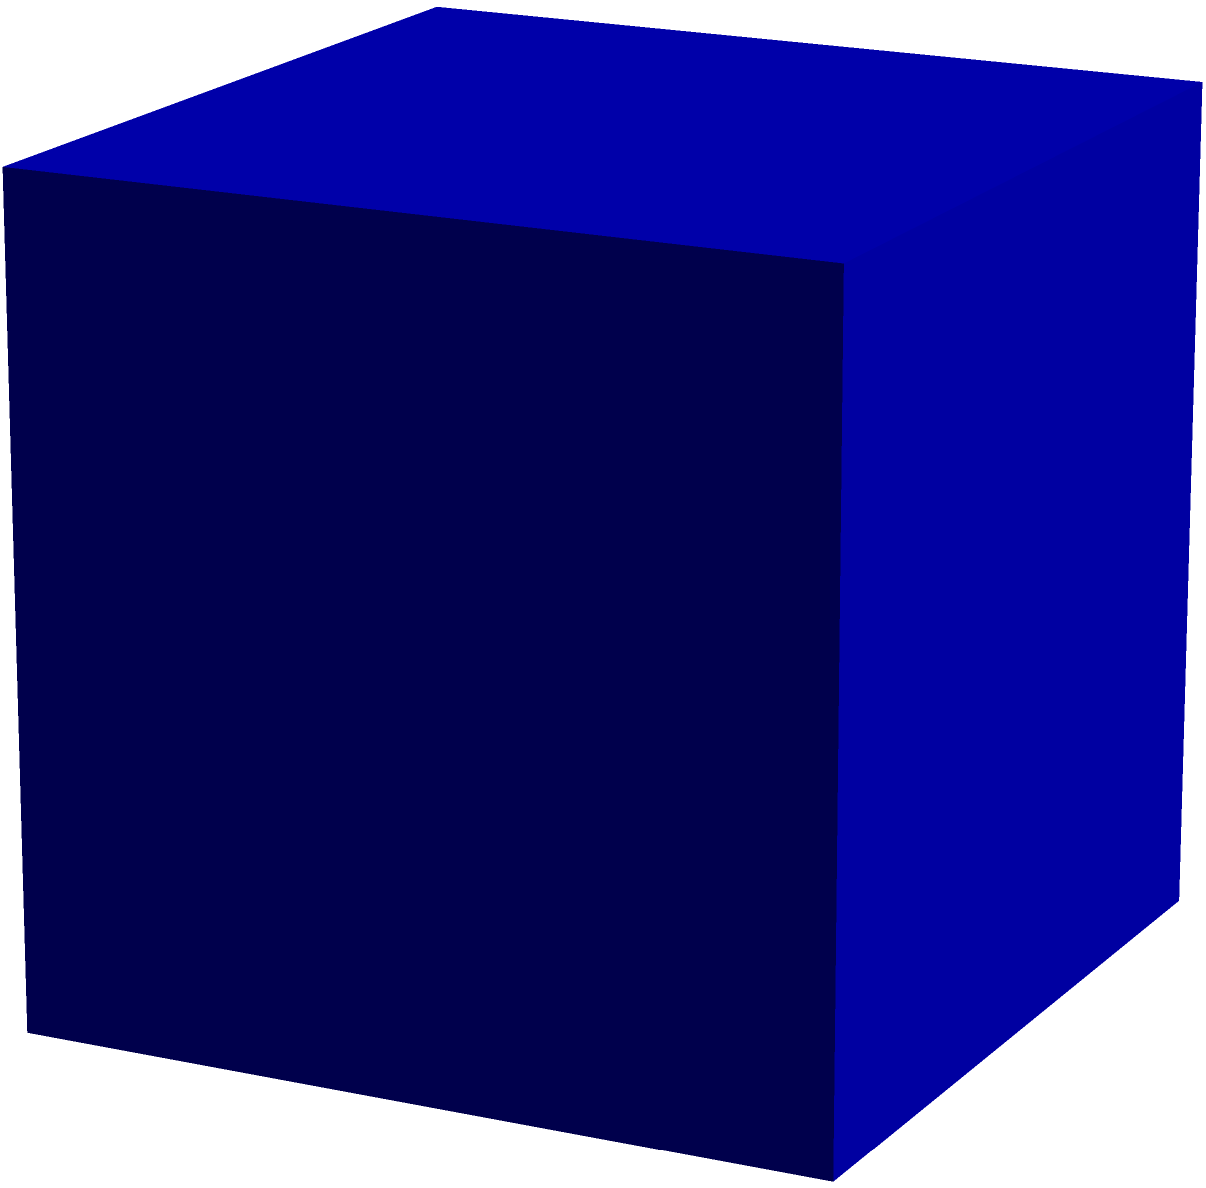In a cube with side length $a$, a sphere is inscribed such that it touches all faces of the cube. What is the volume of this inscribed sphere in terms of $a$? Let's approach this step-by-step:

1) First, we need to understand the relationship between the cube's side length and the sphere's diameter. The sphere's diameter is equal to the cube's side length, $a$.

2) The radius of the sphere, $r$, is half of its diameter. So:
   $r = \frac{a}{2}$

3) The volume of a sphere is given by the formula:
   $V_{sphere} = \frac{4}{3}\pi r^3$

4) Substituting our radius:
   $V_{sphere} = \frac{4}{3}\pi (\frac{a}{2})^3$

5) Simplify:
   $V_{sphere} = \frac{4}{3}\pi \frac{a^3}{8}$

6) Further simplification:
   $V_{sphere} = \frac{\pi a^3}{6}$

Therefore, the volume of the inscribed sphere is $\frac{\pi a^3}{6}$.
Answer: $\frac{\pi a^3}{6}$ 